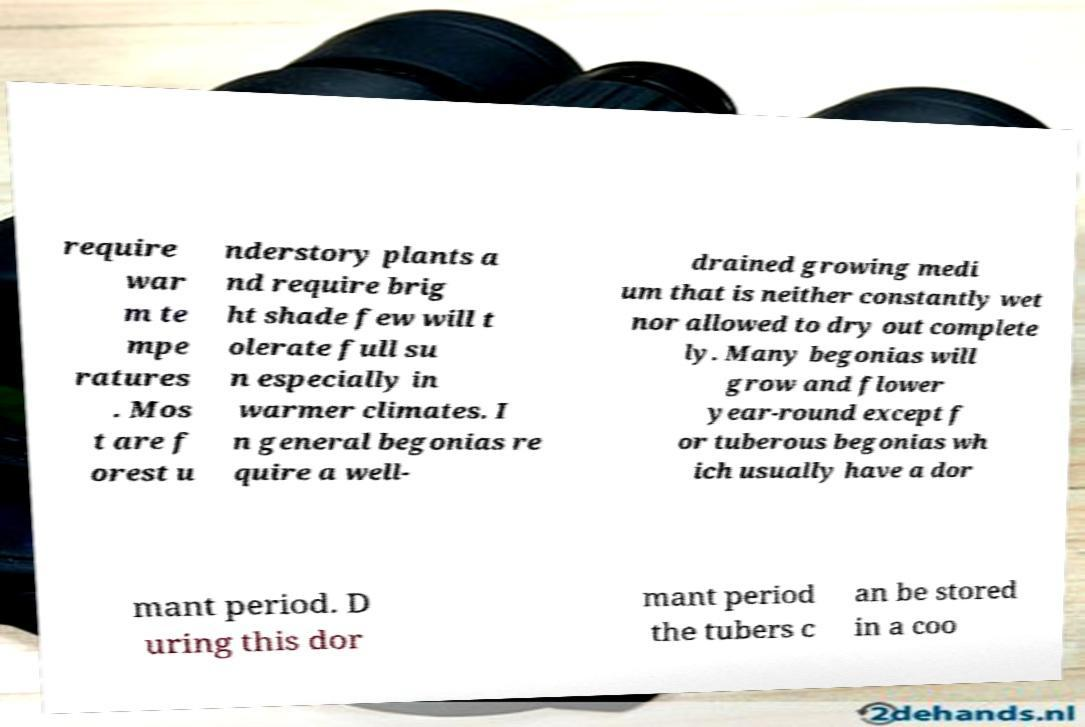There's text embedded in this image that I need extracted. Can you transcribe it verbatim? require war m te mpe ratures . Mos t are f orest u nderstory plants a nd require brig ht shade few will t olerate full su n especially in warmer climates. I n general begonias re quire a well- drained growing medi um that is neither constantly wet nor allowed to dry out complete ly. Many begonias will grow and flower year-round except f or tuberous begonias wh ich usually have a dor mant period. D uring this dor mant period the tubers c an be stored in a coo 